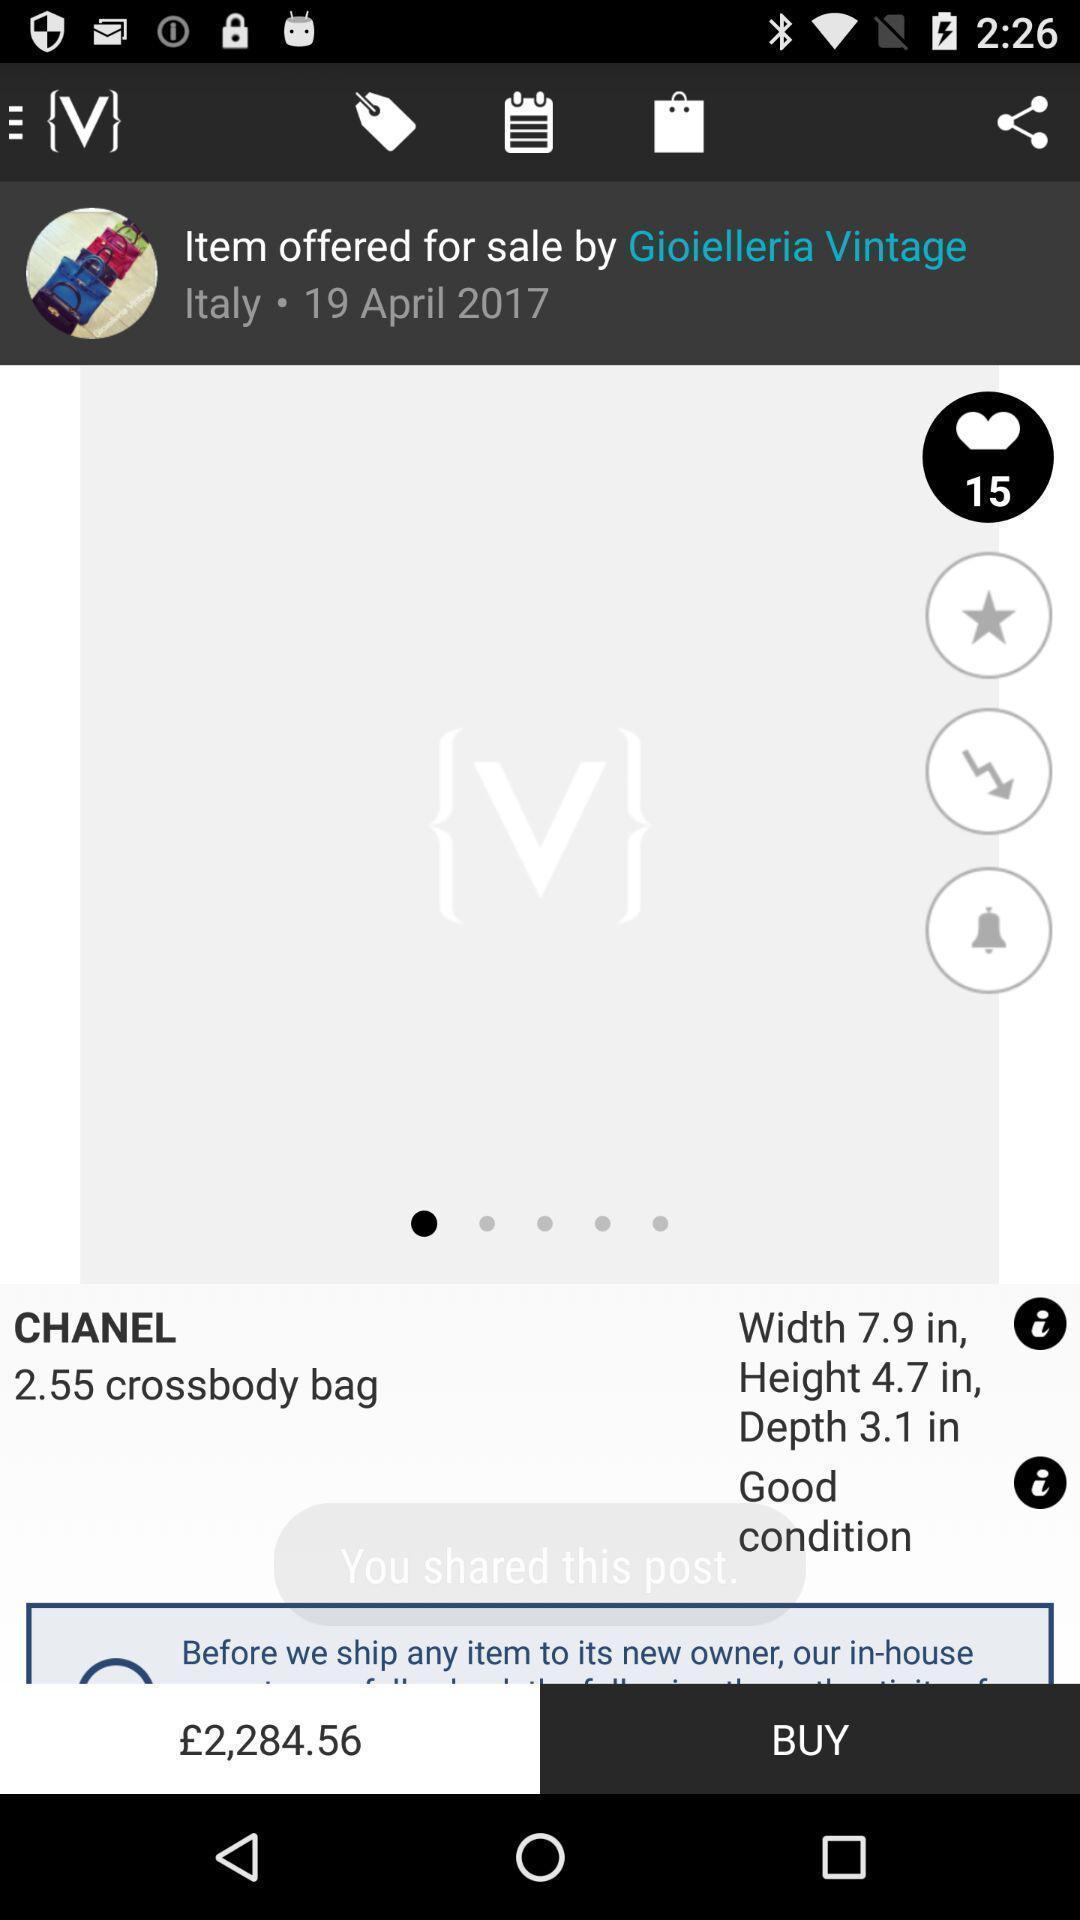Describe this image in words. Screen displaying page of an shopping application. 